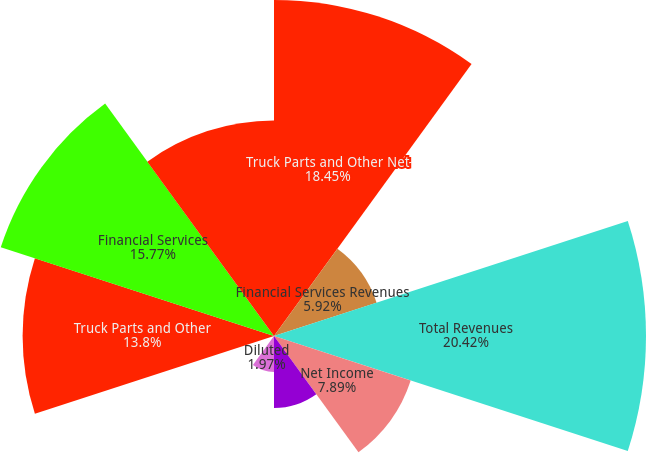Convert chart. <chart><loc_0><loc_0><loc_500><loc_500><pie_chart><fcel>Truck Parts and Other Net<fcel>Financial Services Revenues<fcel>Total Revenues<fcel>Net Income<fcel>Basic<fcel>Diluted<fcel>Cash Dividends Declared Per<fcel>Truck Parts and Other<fcel>Financial Services<fcel>Financial Services Debt<nl><fcel>18.45%<fcel>5.92%<fcel>20.42%<fcel>7.89%<fcel>3.95%<fcel>1.97%<fcel>0.0%<fcel>13.8%<fcel>15.77%<fcel>11.83%<nl></chart> 